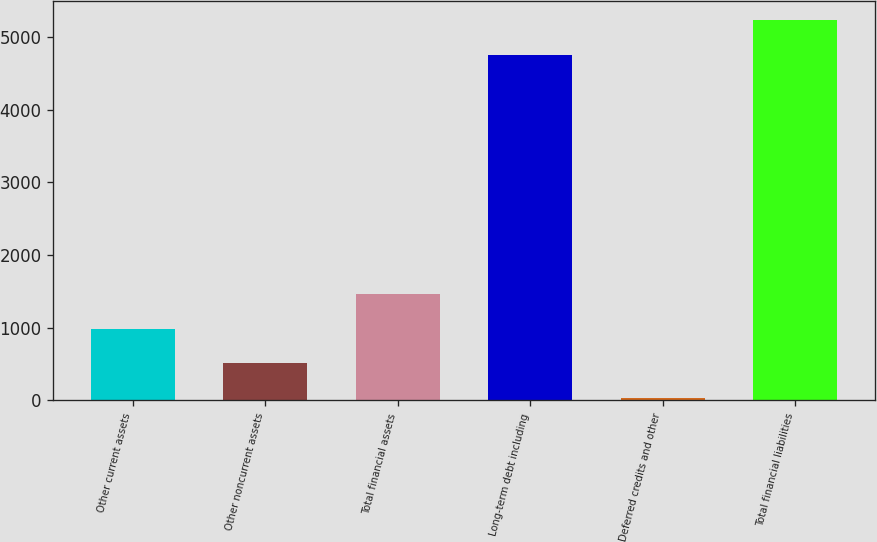Convert chart. <chart><loc_0><loc_0><loc_500><loc_500><bar_chart><fcel>Other current assets<fcel>Other noncurrent assets<fcel>Total financial assets<fcel>Long-term debt including<fcel>Deferred credits and other<fcel>Total financial liabilities<nl><fcel>988.6<fcel>513.3<fcel>1463.9<fcel>4753<fcel>38<fcel>5228.3<nl></chart> 